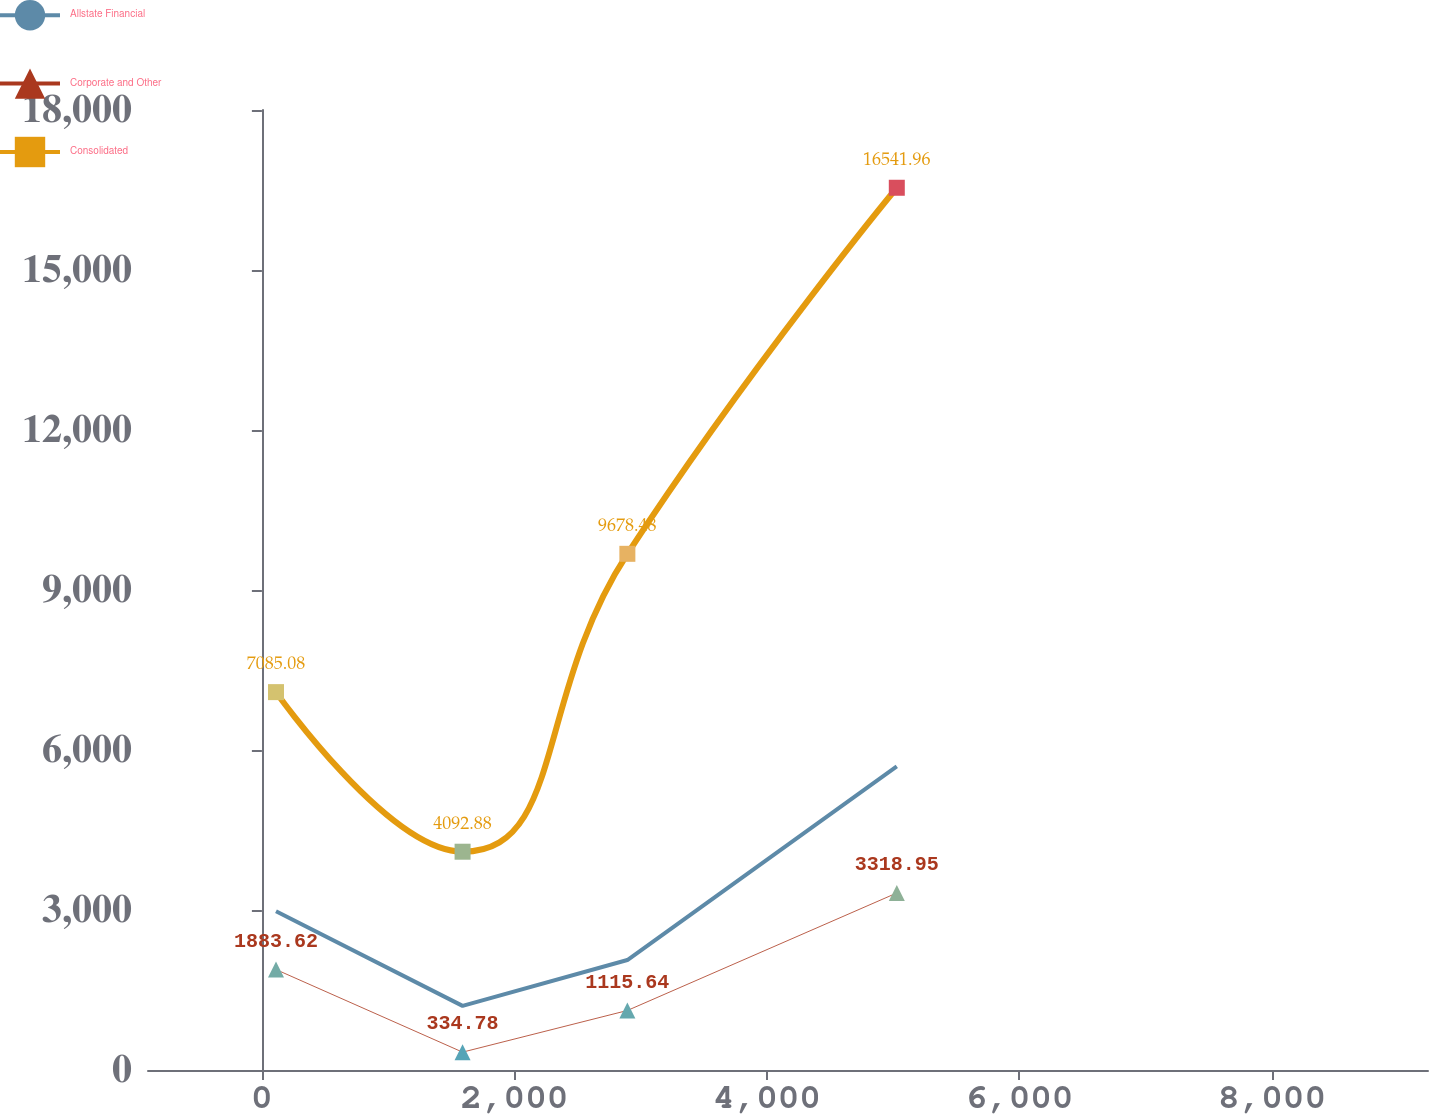Convert chart to OTSL. <chart><loc_0><loc_0><loc_500><loc_500><line_chart><ecel><fcel>Allstate Financial<fcel>Corporate and Other<fcel>Consolidated<nl><fcel>111.72<fcel>2977.96<fcel>1883.62<fcel>7085.08<nl><fcel>1589.41<fcel>1201.9<fcel>334.78<fcel>4092.88<nl><fcel>2894.54<fcel>2061.56<fcel>1115.64<fcel>9678.48<nl><fcel>5028.4<fcel>5694.08<fcel>3318.95<fcel>16542<nl><fcel>10249.3<fcel>7.2<fcel>3.2<fcel>20.37<nl></chart> 